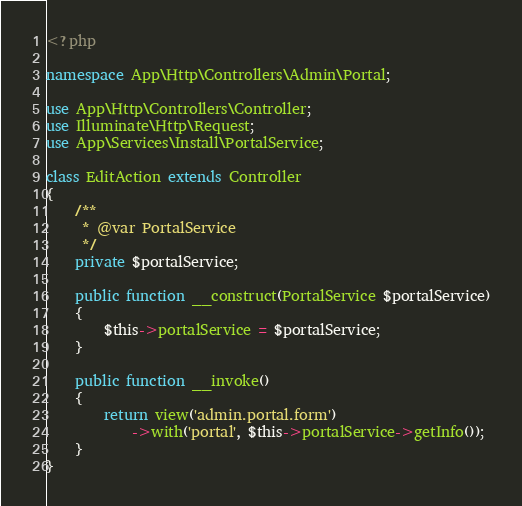Convert code to text. <code><loc_0><loc_0><loc_500><loc_500><_PHP_><?php

namespace App\Http\Controllers\Admin\Portal;

use App\Http\Controllers\Controller;
use Illuminate\Http\Request;
use App\Services\Install\PortalService;

class EditAction extends Controller
{
    /**
     * @var PortalService
     */
    private $portalService;

    public function __construct(PortalService $portalService)
    {
        $this->portalService = $portalService;
    }

    public function __invoke()
    {
        return view('admin.portal.form')
            ->with('portal', $this->portalService->getInfo());
    }
}
</code> 